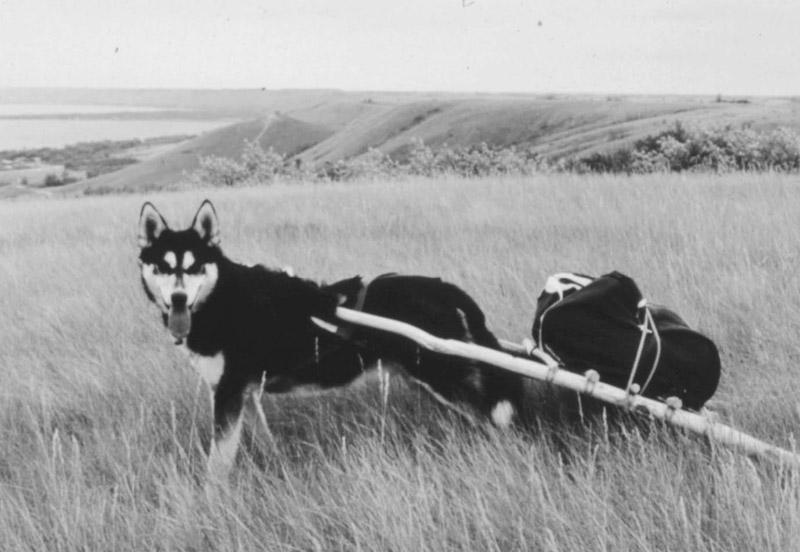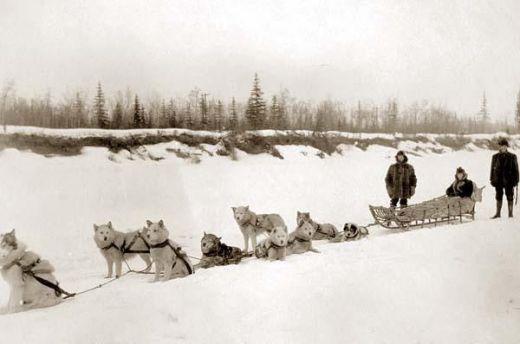The first image is the image on the left, the second image is the image on the right. Given the left and right images, does the statement "One of the images contains no more than two dogs." hold true? Answer yes or no. Yes. 